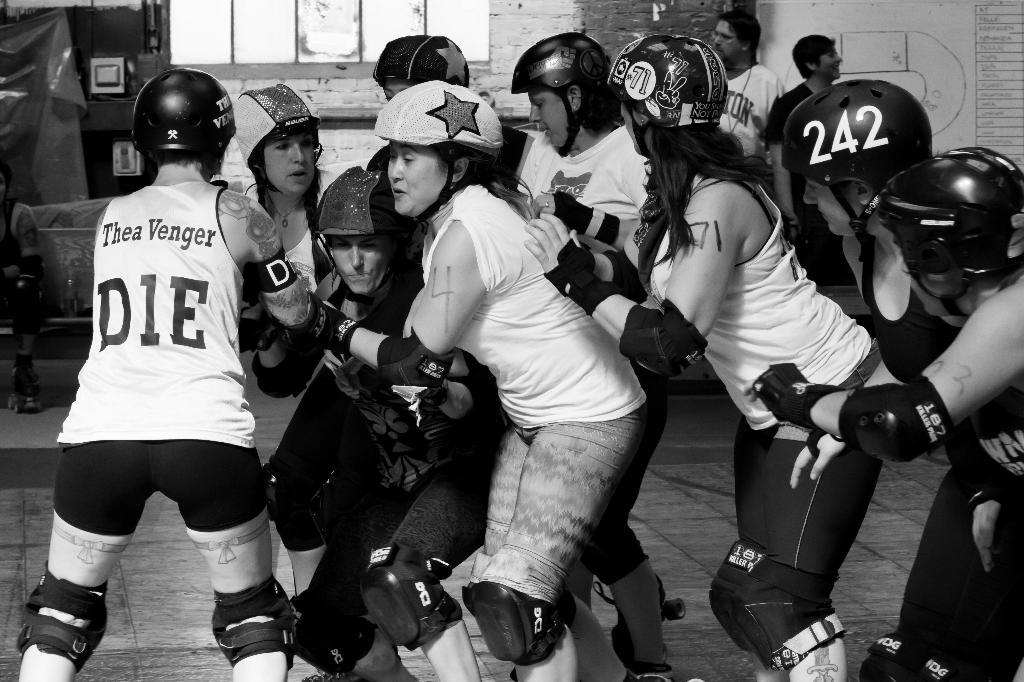How many people are in the image? There are people in the image, but the exact number is not specified. What are the people doing in the image? The people are standing and appear to be playing a game. What protective gear are the people wearing? The people are wearing helmets. What can be seen in the background of the image? There is a wall and a window in the background of the image. What type of houses can be seen in the advertisement in the image? There is no advertisement present in the image, and therefore no houses can be seen in it. 